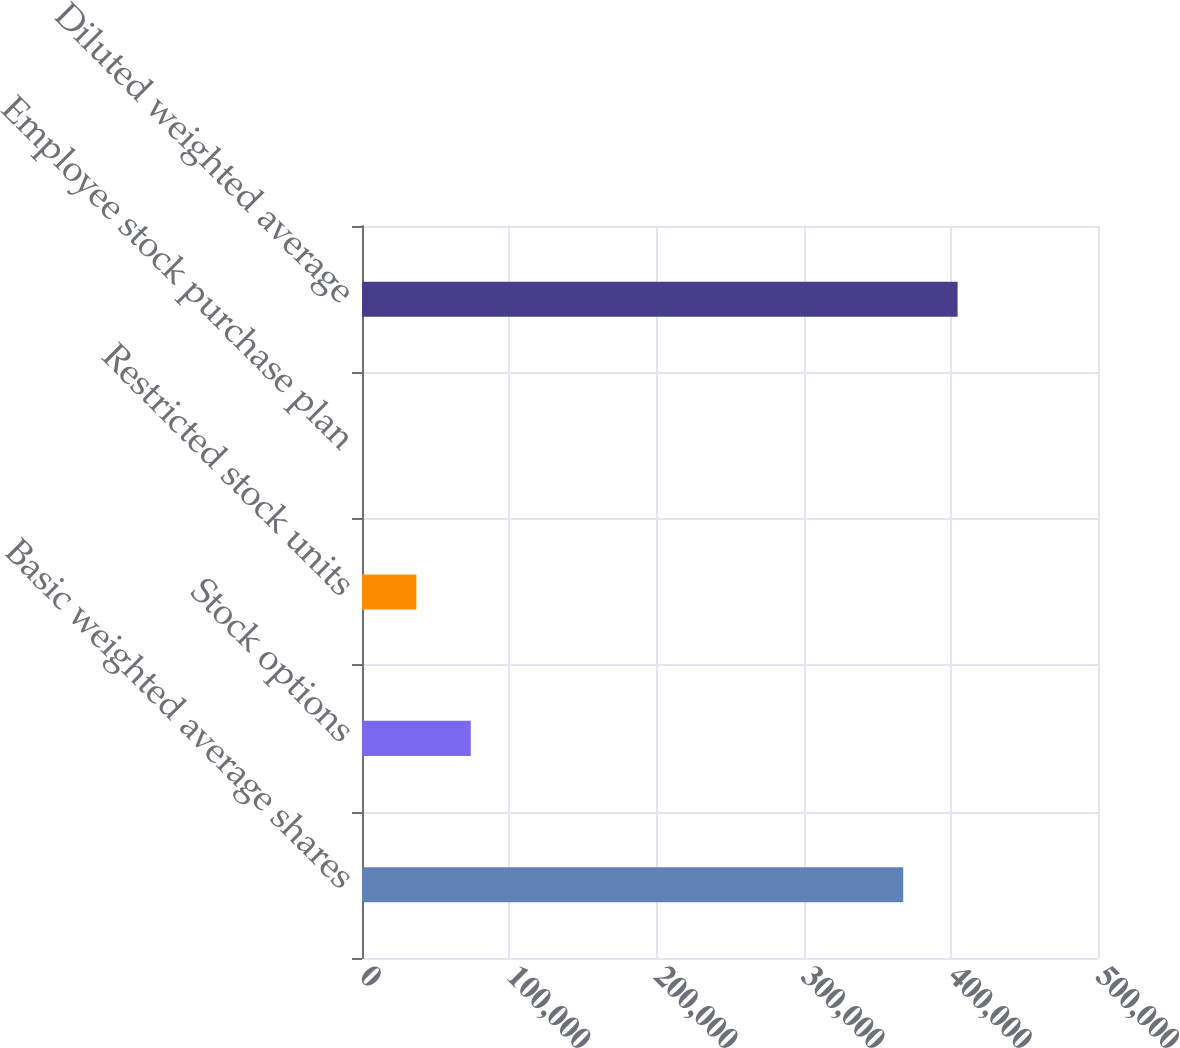Convert chart to OTSL. <chart><loc_0><loc_0><loc_500><loc_500><bar_chart><fcel>Basic weighted average shares<fcel>Stock options<fcel>Restricted stock units<fcel>Employee stock purchase plan<fcel>Diluted weighted average<nl><fcel>367680<fcel>73888.4<fcel>36946.2<fcel>4<fcel>404622<nl></chart> 